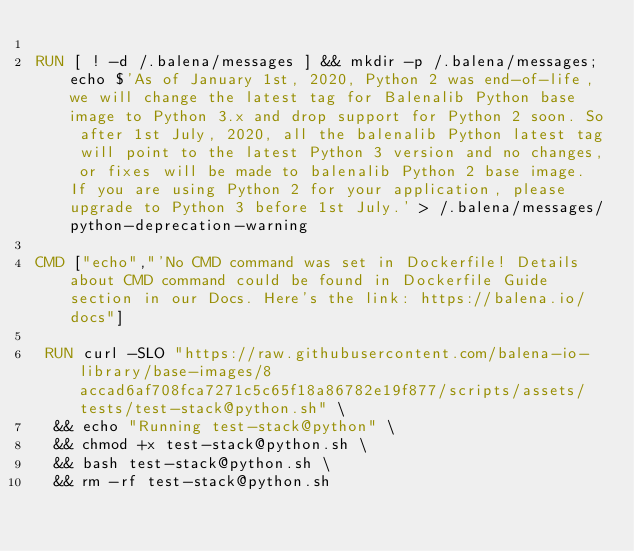Convert code to text. <code><loc_0><loc_0><loc_500><loc_500><_Dockerfile_>
RUN [ ! -d /.balena/messages ] && mkdir -p /.balena/messages; echo $'As of January 1st, 2020, Python 2 was end-of-life, we will change the latest tag for Balenalib Python base image to Python 3.x and drop support for Python 2 soon. So after 1st July, 2020, all the balenalib Python latest tag will point to the latest Python 3 version and no changes, or fixes will be made to balenalib Python 2 base image. If you are using Python 2 for your application, please upgrade to Python 3 before 1st July.' > /.balena/messages/python-deprecation-warning

CMD ["echo","'No CMD command was set in Dockerfile! Details about CMD command could be found in Dockerfile Guide section in our Docs. Here's the link: https://balena.io/docs"]

 RUN curl -SLO "https://raw.githubusercontent.com/balena-io-library/base-images/8accad6af708fca7271c5c65f18a86782e19f877/scripts/assets/tests/test-stack@python.sh" \
  && echo "Running test-stack@python" \
  && chmod +x test-stack@python.sh \
  && bash test-stack@python.sh \
  && rm -rf test-stack@python.sh 
</code> 